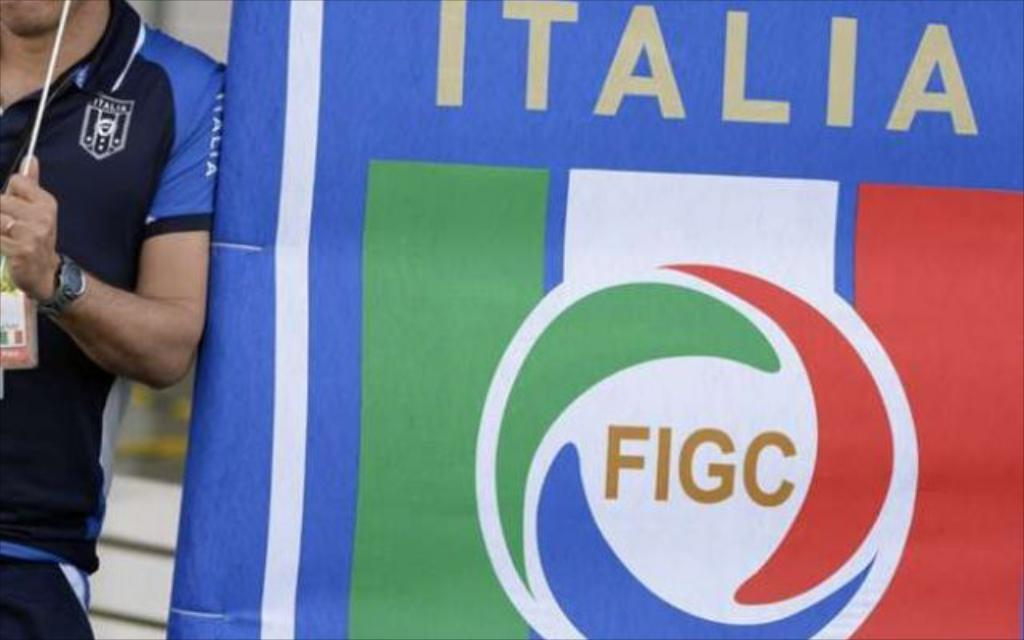<image>
Give a short and clear explanation of the subsequent image. An Italia banner bears a FICG logo in the center. 